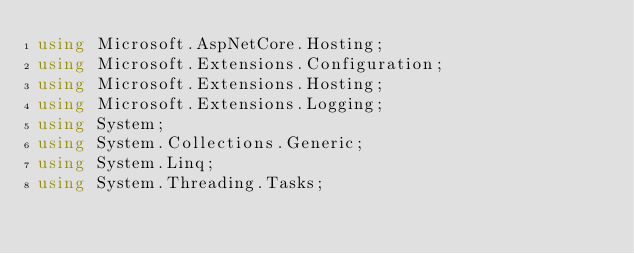<code> <loc_0><loc_0><loc_500><loc_500><_C#_>using Microsoft.AspNetCore.Hosting;
using Microsoft.Extensions.Configuration;
using Microsoft.Extensions.Hosting;
using Microsoft.Extensions.Logging;
using System;
using System.Collections.Generic;
using System.Linq;
using System.Threading.Tasks;
</code> 